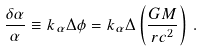<formula> <loc_0><loc_0><loc_500><loc_500>\frac { \delta \alpha } { \alpha } \equiv k _ { \alpha } \Delta \phi = k _ { \alpha } \Delta \left ( \frac { G M } { r c ^ { 2 } } \right ) \, .</formula> 